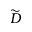<formula> <loc_0><loc_0><loc_500><loc_500>\widetilde { D }</formula> 